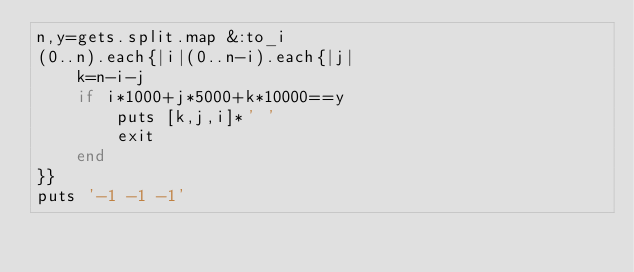Convert code to text. <code><loc_0><loc_0><loc_500><loc_500><_Ruby_>n,y=gets.split.map &:to_i
(0..n).each{|i|(0..n-i).each{|j|
	k=n-i-j
	if i*1000+j*5000+k*10000==y
		puts [k,j,i]*' '
		exit
	end
}}
puts '-1 -1 -1'</code> 